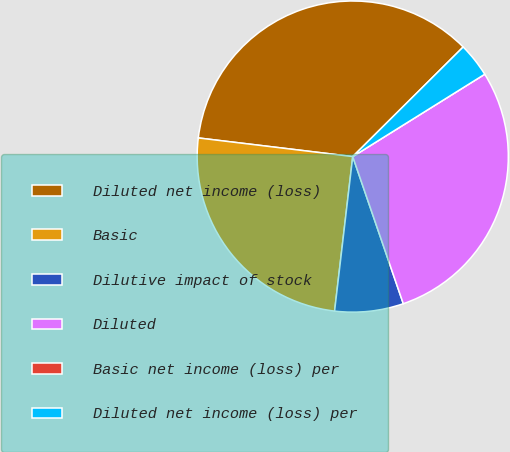Convert chart to OTSL. <chart><loc_0><loc_0><loc_500><loc_500><pie_chart><fcel>Diluted net income (loss)<fcel>Basic<fcel>Dilutive impact of stock<fcel>Diluted<fcel>Basic net income (loss) per<fcel>Diluted net income (loss) per<nl><fcel>35.65%<fcel>25.05%<fcel>7.13%<fcel>28.61%<fcel>0.0%<fcel>3.56%<nl></chart> 